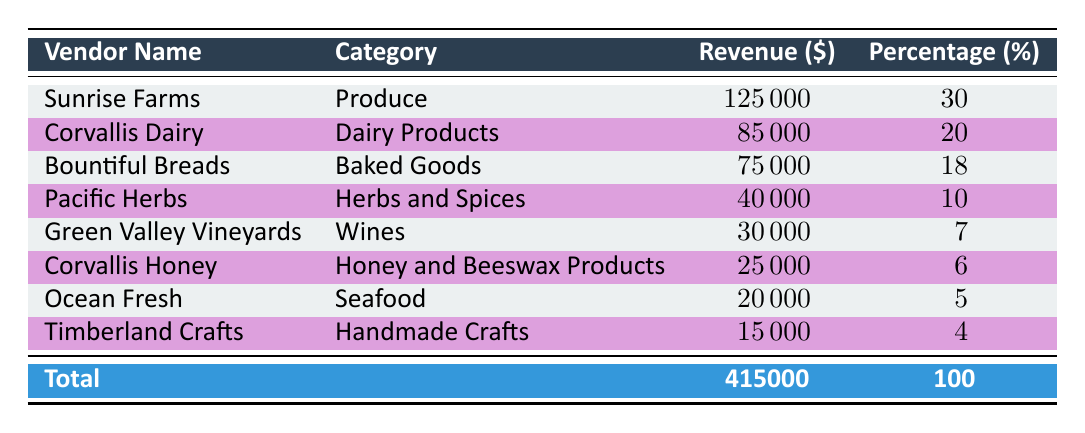What is the total revenue earned by all vendors in 2022? To find the total revenue, we look at the last row in the table, which shows the total as 415000. This was directly computed by summing up all individual vendor revenues listed above it.
Answer: 415000 Which vendor earned the highest revenue in 2022? By scanning the Revenue column, we see that Sunrise Farms has the highest revenue at 125000. There are no other vendors with a revenue equal to or greater than this amount.
Answer: Sunrise Farms What percentage of revenue did Corvallis Dairy contribute? The table directly lists Corvallis Dairy's percentage contribution as 20%. This is a straightforward retrieval from the Percentage column for that vendor.
Answer: 20 How much more revenue did Sunrise Farms earn than Timberland Crafts? First, we check Sunrise Farms' revenue, which is 125000, and Timberland Crafts', which is 15000. We then subtract the two values: 125000 - 15000 = 110000. This shows how much more revenue Sunrise Farms earned compared to Timberland Crafts.
Answer: 110000 Is the revenue from Ocean Fresh greater than the combined revenue from Timberland Crafts and Corvallis Honey? First, we find Ocean Fresh's revenue, which is 20000. Next, we sum Timberland Crafts' (15000) and Corvallis Honey's (25000) revenues: 15000 + 25000 = 40000. Since 20000 is less than 40000, the statement is false.
Answer: No What is the average revenue percentage for all vendors? To find the average percentage, we first sum all listed percentages: 30 + 20 + 18 + 10 + 7 + 6 + 5 + 4 = 100. Since there are 8 vendors, we divide by 8: 100 / 8 = 12.5. Therefore, the average revenue percentage among all vendors is calculated.
Answer: 12.5 Which category made the least revenue in 2022? Scanning the Revenue column, we see that Timberland Crafts earned the least revenue at 15000. This is the lowest amount when compared to the other vendors in the list.
Answer: Handmade Crafts How much revenue is generated by produce vendors compared to dairy vendors? The revenue from produce vendor Sunrise Farms is 125000. From dairy, Corvallis Dairy's revenue is 85000. Comparing these, we find 125000 (produce) - 85000 (dairy) = 40000, showing that produce vendors generated significantly more revenue.
Answer: 40000 